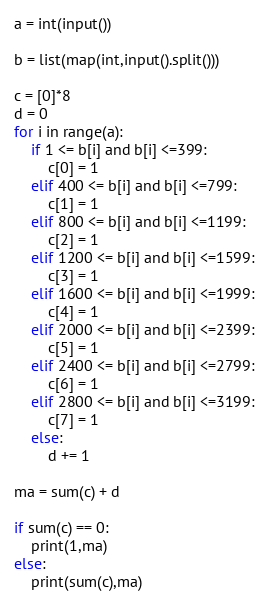<code> <loc_0><loc_0><loc_500><loc_500><_Python_>a = int(input())

b = list(map(int,input().split()))

c = [0]*8
d = 0
for i in range(a):
	if 1 <= b[i] and b[i] <=399:
		c[0] = 1
	elif 400 <= b[i] and b[i] <=799:
		c[1] = 1
	elif 800 <= b[i] and b[i] <=1199:
		c[2] = 1
	elif 1200 <= b[i] and b[i] <=1599:
		c[3] = 1
	elif 1600 <= b[i] and b[i] <=1999:
		c[4] = 1
	elif 2000 <= b[i] and b[i] <=2399:
		c[5] = 1
	elif 2400 <= b[i] and b[i] <=2799:
		c[6] = 1
	elif 2800 <= b[i] and b[i] <=3199:
		c[7] = 1
	else:
		d += 1

ma = sum(c) + d

if sum(c) == 0:
	print(1,ma)
else:
	print(sum(c),ma)</code> 